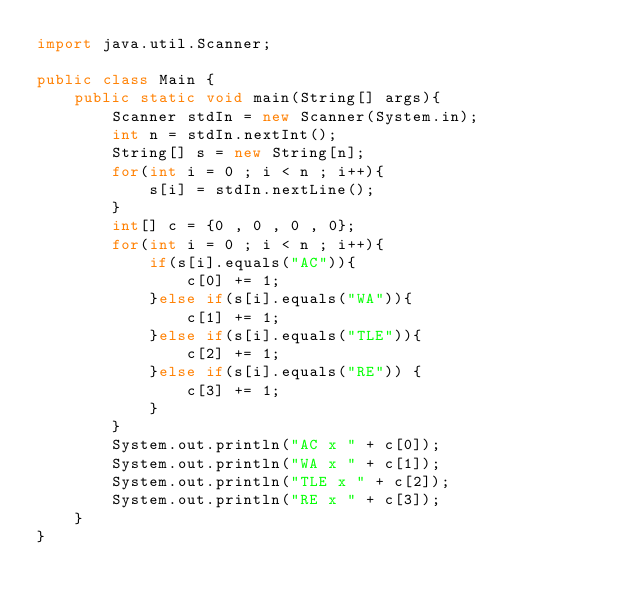<code> <loc_0><loc_0><loc_500><loc_500><_Java_>import java.util.Scanner;

public class Main {
    public static void main(String[] args){
        Scanner stdIn = new Scanner(System.in);
        int n = stdIn.nextInt();
        String[] s = new String[n];
        for(int i = 0 ; i < n ; i++){
            s[i] = stdIn.nextLine();
        }
        int[] c = {0 , 0 , 0 , 0};
        for(int i = 0 ; i < n ; i++){
            if(s[i].equals("AC")){
                c[0] += 1;
            }else if(s[i].equals("WA")){
                c[1] += 1;
            }else if(s[i].equals("TLE")){
                c[2] += 1;
            }else if(s[i].equals("RE")) {
                c[3] += 1;
            }
        }
        System.out.println("AC x " + c[0]);
        System.out.println("WA x " + c[1]);
        System.out.println("TLE x " + c[2]);
        System.out.println("RE x " + c[3]);
    }
}
</code> 